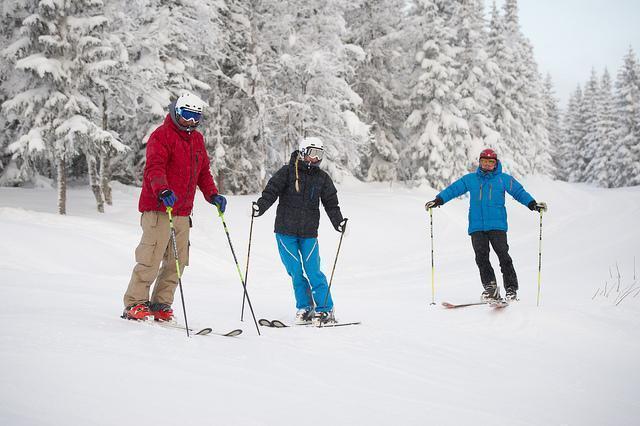A snowblade is made of what?
Indicate the correct choice and explain in the format: 'Answer: answer
Rationale: rationale.'
Options: Wood, plastic, aluminum, copper. Answer: wood.
Rationale: The snowblade is made of material from trees. 